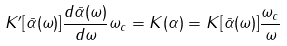<formula> <loc_0><loc_0><loc_500><loc_500>K ^ { \prime } [ { \bar { \alpha } } ( \omega ) ] \frac { d { \bar { \alpha } } ( \omega ) } { d \omega } \omega _ { c } = K ( \alpha ) = K [ { \bar { \alpha } } ( \omega ) ] \frac { \omega _ { c } } { \omega }</formula> 